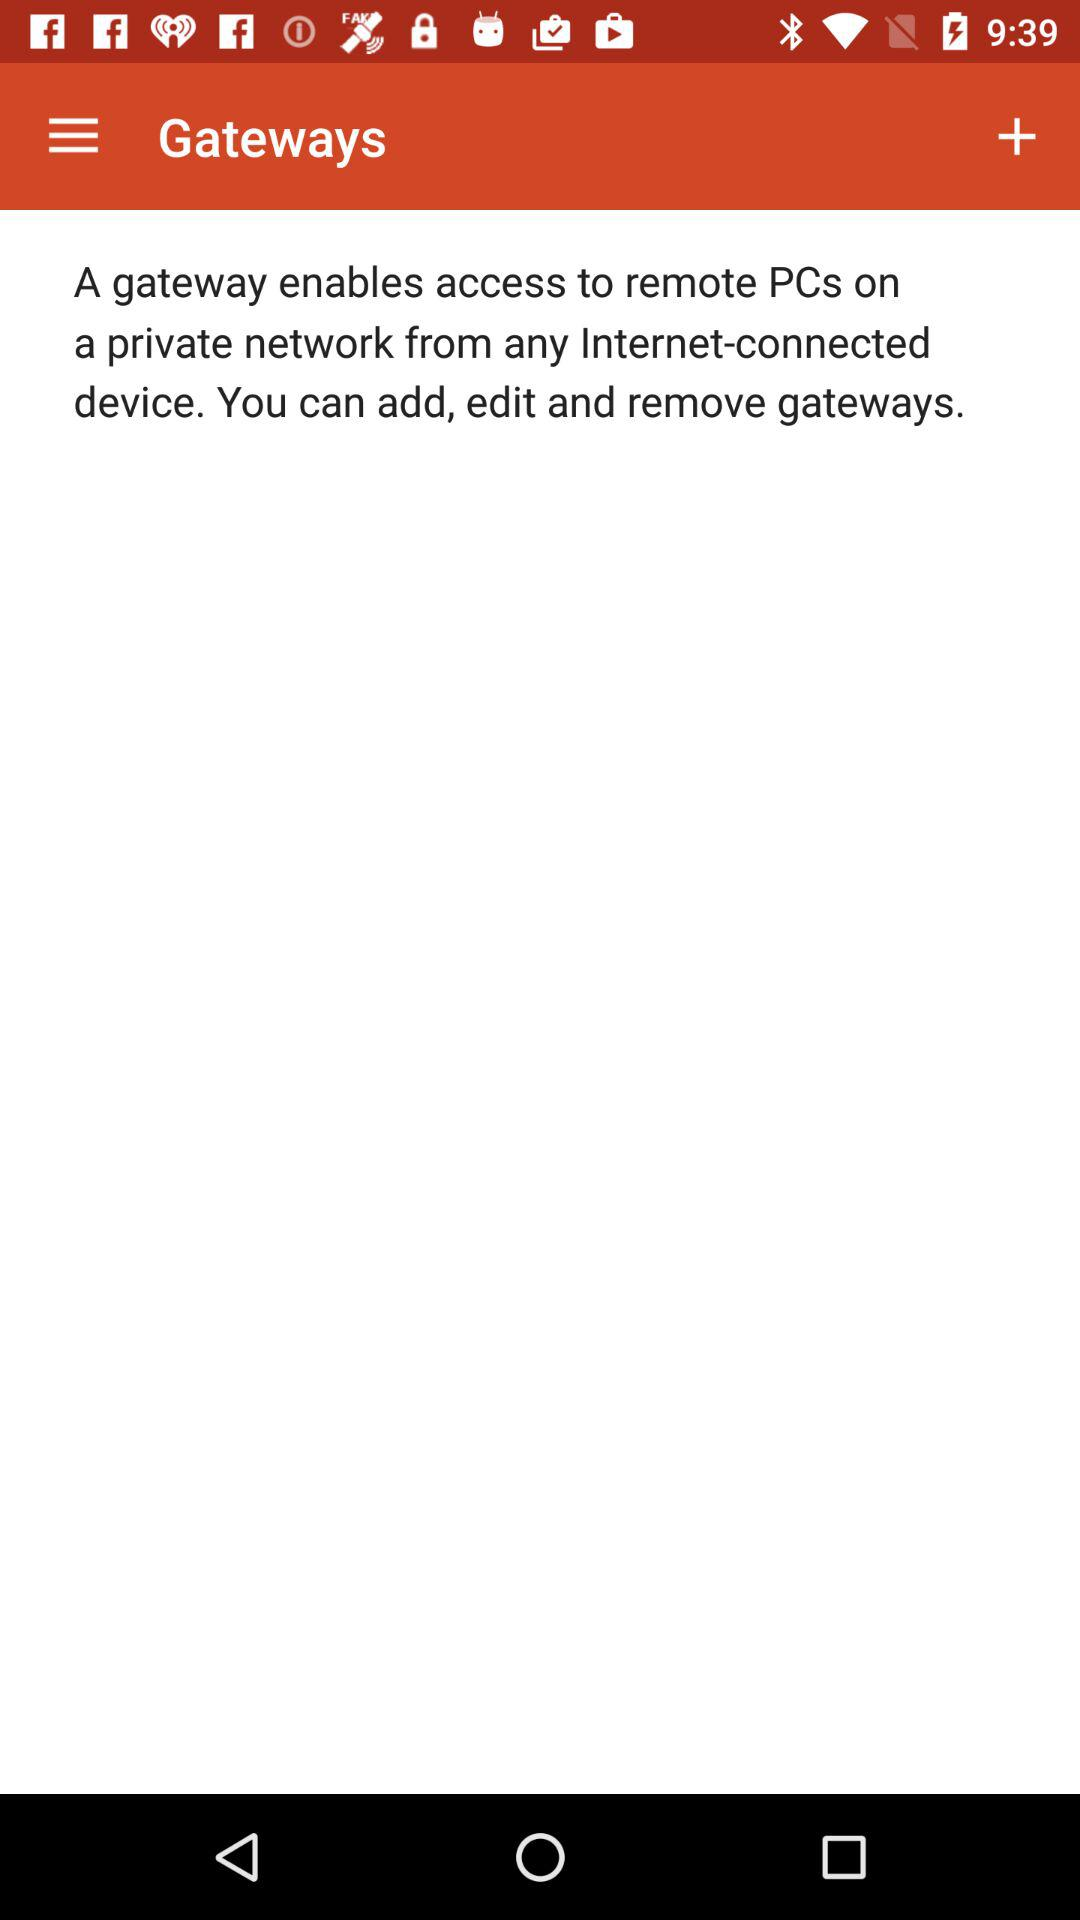What is the name of the application? The name of the application is "Gateways". 